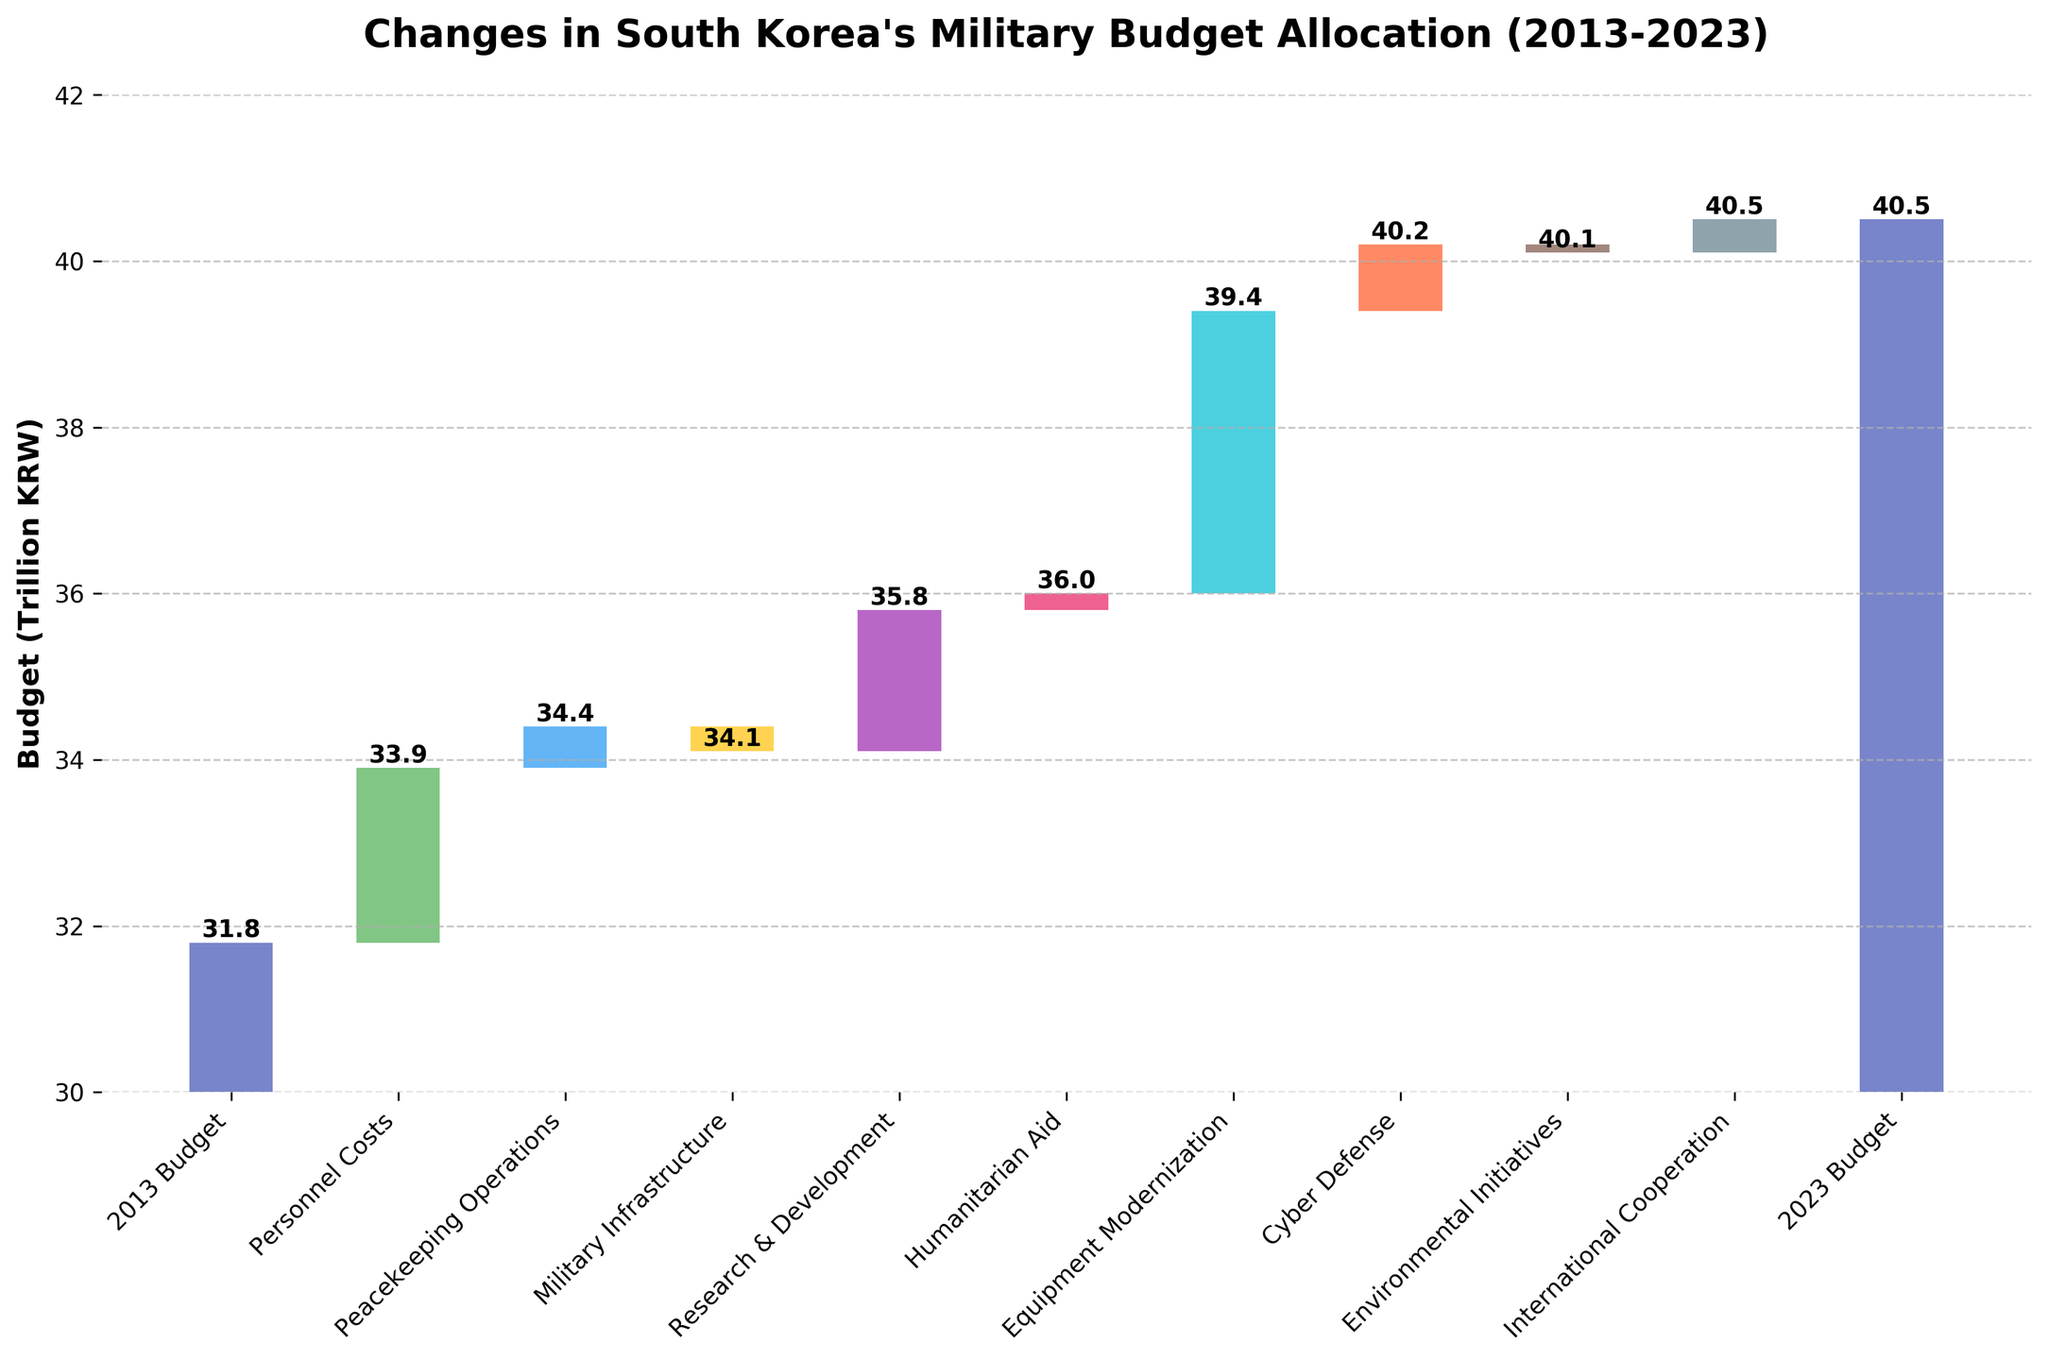What is the title of the chart and what years does it cover? The title is "Changes in South Korea's Military Budget Allocation (2013-2023)". The years covered are from 2013 to 2023, as stated in the title.
Answer: Changes in South Korea's Military Budget Allocation (2013-2023) What is the overall increase in South Korea’s military budget from 2013 to 2023? According to the chart, the military budget in 2013 was 31.8 trillion KRW and in 2023 it is 40.5 trillion KRW. The increase is 40.5 - 31.8 = 8.7 trillion KRW.
Answer: 8.7 trillion KRW Which category contributed the most to the budget increase? By examining the bars that represent increases, the "Equipment Modernization" category has the largest increase of +3.4 trillion KRW.
Answer: Equipment Modernization How many categories showed a decrease in budget allocation over the past decade? By counting the negative values, there are two categories: "Military Infrastructure" and "Environmental Initiatives."
Answer: 2 What is the value of the Personnel Costs budget increase? The Personnel Costs increase is represented by the bar labeled "+2.1".
Answer: +2.1 trillion KRW What was the budget value after accounting for Personnel Costs and Peacekeeping Operations in the cumulative calculation? Starting with 31.8 trillion KRW in 2013, adding Personnel Costs (+2.1) gives 33.9. Adding Peacekeeping Operations (+0.5) results in 34.4 trillion KRW.
Answer: 34.4 trillion KRW Compare the budget changes between Cyber Defense and Humanitarian Aid, and identify which received a larger increase. Cyber Defense increased by +0.8 trillion KRW, while Humanitarian Aid increased by +0.2 trillion KRW. Cyber Defense received a larger increase.
Answer: Cyber Defense What is the final budget value after summing all the changes? According to the cumulative values shown in the waterfall chart, the final value, which is the 2023 budget, is 40.5 trillion KRW.
Answer: 40.5 trillion KRW What was the impact of Military Infrastructure and Environmental Initiatives on the total budget? Military Infrastructure decreased the budget by -0.3 trillion KRW, and Environmental Initiatives decreased it by -0.1 trillion KRW. The total combined impact is -0.4 trillion KRW.
Answer: -0.4 trillion KRW 